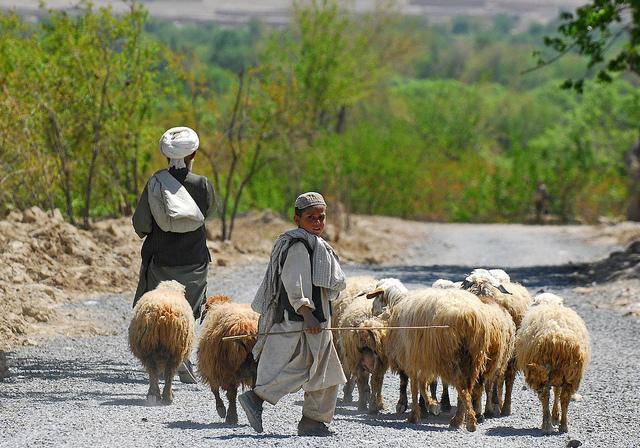How many sheep are there?
Give a very brief answer. 6. How many people are there?
Give a very brief answer. 2. 